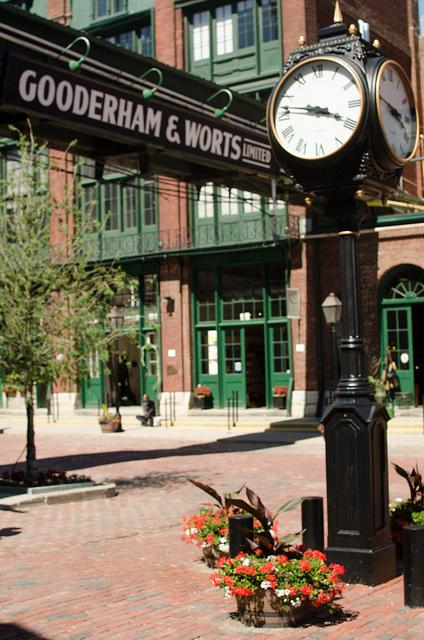In which setting is this clock?

Choices:
A) tundra
B) suburban
C) rural
D) urban urban 